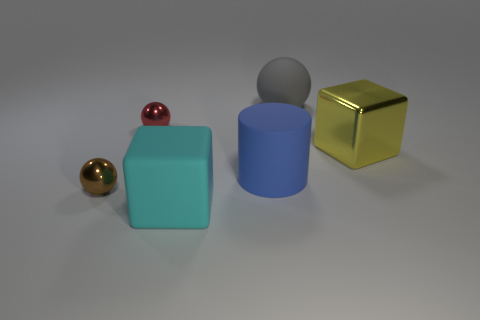What time of day does the lighting in the image suggest? The lighting in the image does not strongly indicate a specific time of day as it appears to be a studio setup with neutral and homogenous illumination. The lack of shadows and soft light points to an indoor photo shoot with artificial lighting rather than natural light from the sun. 